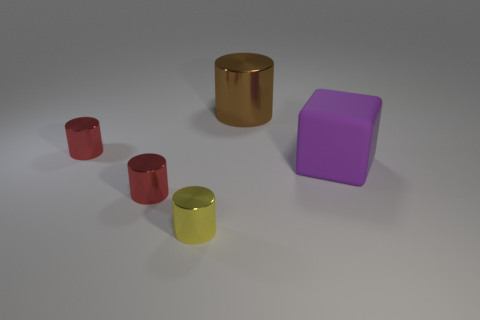Add 4 cyan metal blocks. How many objects exist? 9 Subtract all cubes. How many objects are left? 4 Subtract 1 purple blocks. How many objects are left? 4 Subtract all blocks. Subtract all tiny red metal blocks. How many objects are left? 4 Add 5 small yellow shiny things. How many small yellow shiny things are left? 6 Add 2 big red metallic blocks. How many big red metallic blocks exist? 2 